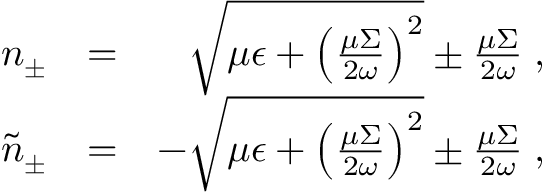<formula> <loc_0><loc_0><loc_500><loc_500>\begin{array} { r l r } { n _ { \pm } } & { = } & { \sqrt { \mu \epsilon + \left ( \frac { \mu \Sigma } { 2 \omega } \right ) ^ { 2 } } \pm \frac { \mu \Sigma } { 2 \omega } \, , } \\ { \tilde { n } _ { \pm } } & { = } & { - \sqrt { \mu \epsilon + \left ( \frac { \mu \Sigma } { 2 \omega } \right ) ^ { 2 } } \pm \frac { \mu \Sigma } { 2 \omega } \, , } \end{array}</formula> 